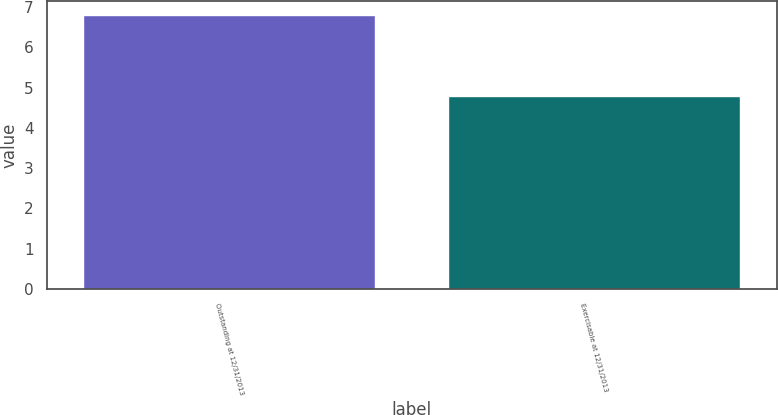Convert chart. <chart><loc_0><loc_0><loc_500><loc_500><bar_chart><fcel>Outstanding at 12/31/2013<fcel>Exercisable at 12/31/2013<nl><fcel>6.8<fcel>4.8<nl></chart> 